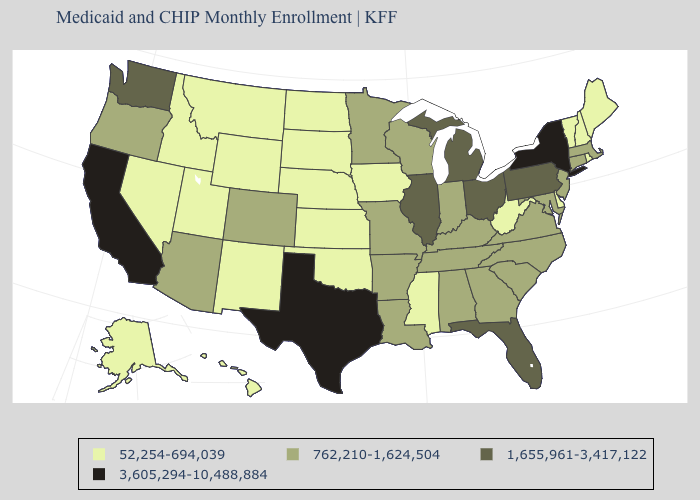Which states have the highest value in the USA?
Quick response, please. California, New York, Texas. Does the first symbol in the legend represent the smallest category?
Quick response, please. Yes. What is the value of Nebraska?
Give a very brief answer. 52,254-694,039. What is the value of Georgia?
Answer briefly. 762,210-1,624,504. What is the highest value in states that border South Dakota?
Keep it brief. 762,210-1,624,504. What is the value of North Dakota?
Keep it brief. 52,254-694,039. Does Pennsylvania have the highest value in the Northeast?
Write a very short answer. No. Name the states that have a value in the range 762,210-1,624,504?
Quick response, please. Alabama, Arizona, Arkansas, Colorado, Connecticut, Georgia, Indiana, Kentucky, Louisiana, Maryland, Massachusetts, Minnesota, Missouri, New Jersey, North Carolina, Oregon, South Carolina, Tennessee, Virginia, Wisconsin. Name the states that have a value in the range 762,210-1,624,504?
Answer briefly. Alabama, Arizona, Arkansas, Colorado, Connecticut, Georgia, Indiana, Kentucky, Louisiana, Maryland, Massachusetts, Minnesota, Missouri, New Jersey, North Carolina, Oregon, South Carolina, Tennessee, Virginia, Wisconsin. What is the highest value in the MidWest ?
Keep it brief. 1,655,961-3,417,122. Does California have a higher value than New York?
Concise answer only. No. Does the map have missing data?
Answer briefly. No. Name the states that have a value in the range 1,655,961-3,417,122?
Give a very brief answer. Florida, Illinois, Michigan, Ohio, Pennsylvania, Washington. Name the states that have a value in the range 1,655,961-3,417,122?
Be succinct. Florida, Illinois, Michigan, Ohio, Pennsylvania, Washington. 